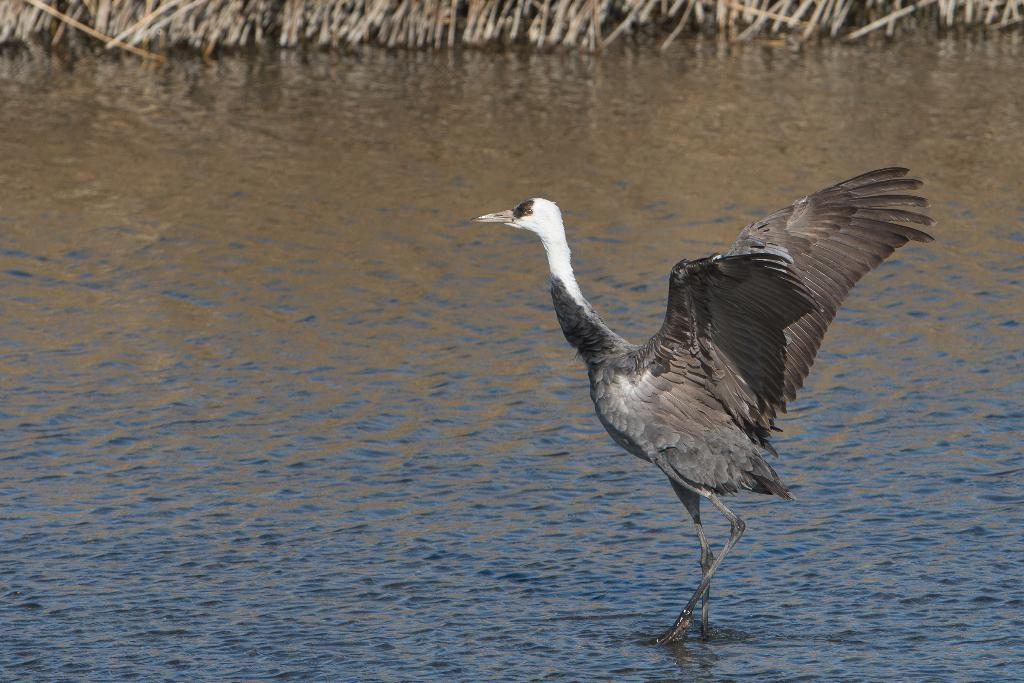What type of animal is in the image? There is a bird in the image. What is the bird doing in the image? The bird is walking in the water. Where is the bird located in the image? The bird is in the middle of the image. What can be seen in the background of the image? There is water visible in the background of the image. What is the woman discussing with the bird in the image? There is no woman present in the image, and therefore no discussion can be observed. 